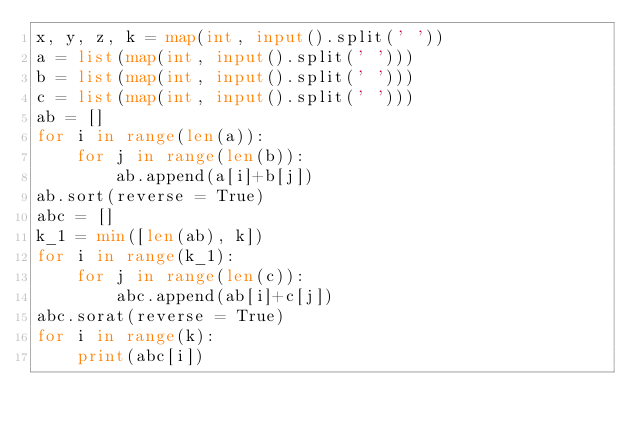Convert code to text. <code><loc_0><loc_0><loc_500><loc_500><_Python_>x, y, z, k = map(int, input().split(' '))
a = list(map(int, input().split(' ')))
b = list(map(int, input().split(' ')))
c = list(map(int, input().split(' ')))
ab = []
for i in range(len(a)):
    for j in range(len(b)):
        ab.append(a[i]+b[j])
ab.sort(reverse = True)
abc = []
k_1 = min([len(ab), k])
for i in range(k_1):
    for j in range(len(c)):
        abc.append(ab[i]+c[j])
abc.sorat(reverse = True)
for i in range(k):
    print(abc[i])</code> 